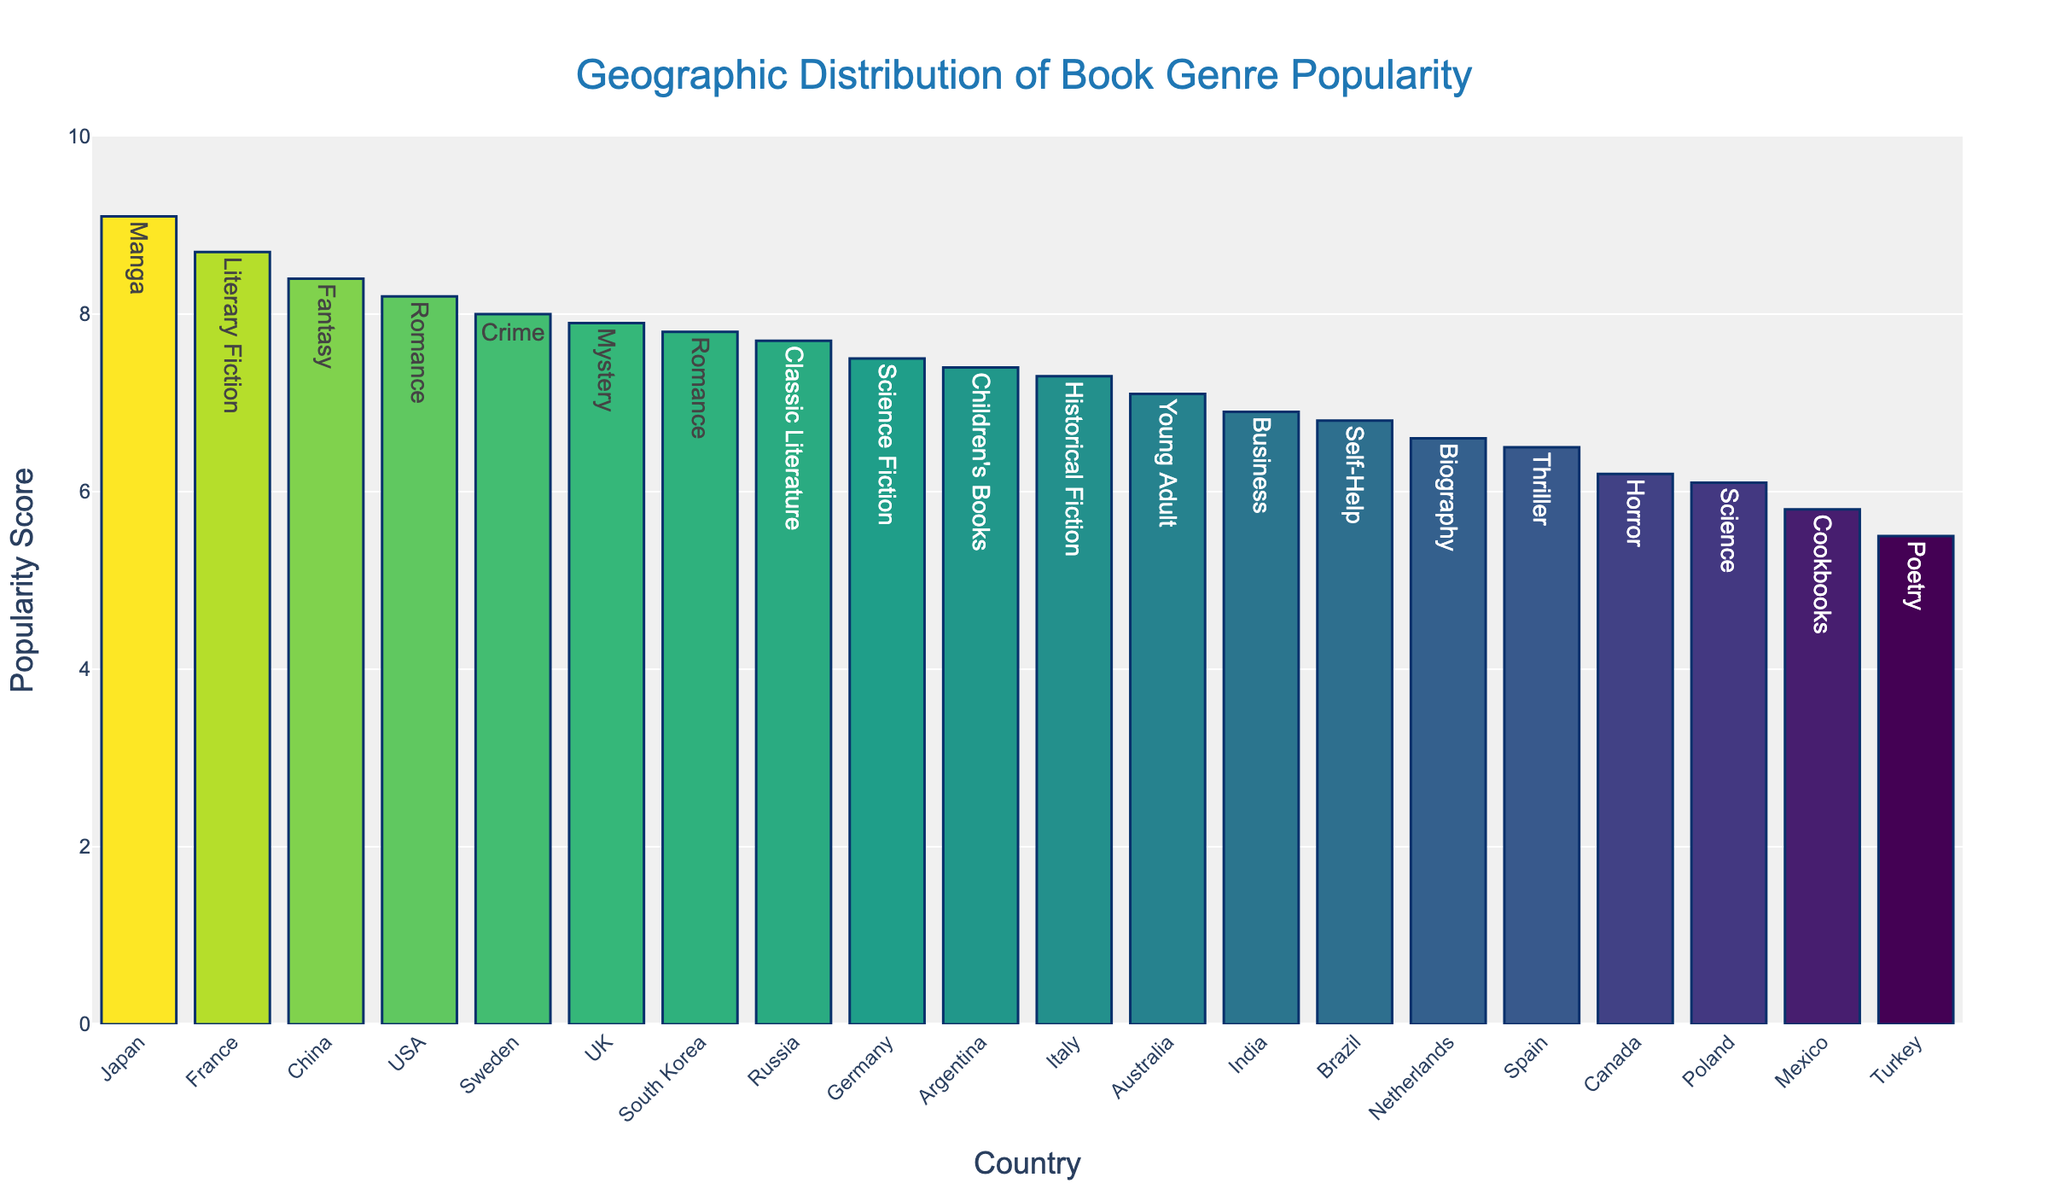What's the title of the figure? The title of the figure is written at the top center of the plot.
Answer: Geographic Distribution of Book Genre Popularity Which country has the highest popularity score? By examining the height of the bars, we notice that the bar for Japan is the tallest.
Answer: Japan What genre is associated with the highest popularity score? The text above the tallest bar indicates the genre for Japan.
Answer: Manga Which countries have a popularity score greater than 8? Identify and list all countries with bars exceeding the y-axis value of 8.
Answer: USA, France, Japan, China, Sweden What's the average popularity score of Romance genres shown in the figure? Locate the countries with the Romance genre. The countries are USA (8.2) and South Korea (7.8). The average is (8.2 + 7.8) / 2.
Answer: 8.0 Which country has the lowest popularity score, and what is the genre? Examine the shortest bar to the left: Turkey. The text above it shows the genre.
Answer: Turkey, Poetry How much more popular is Manga in Japan compared to Self-Help in Brazil? Subtract the popularity score of Brazil from that of Japan (9.1 - 6.8).
Answer: 2.3 What is the difference in popularity scores between the Crime genre in Sweden and the Mystery genre in the UK? Subtract the popularity score of the UK from that of Sweden (8.0 - 7.9).
Answer: 0.1 Which country has the highest popularity score for a genre that includes the term 'fiction'? Locate the countries and genres with Literary Fiction, Science Fiction, and Historical Fiction, then compare their scores. France has the highest with 8.7.
Answer: France Count the number of countries with a popularity score below 7. Identify and count all bars with a height corresponding to a value less than 7. The countries are Mexico, Turkey, Poland, Canada, and Spain.
Answer: 5 